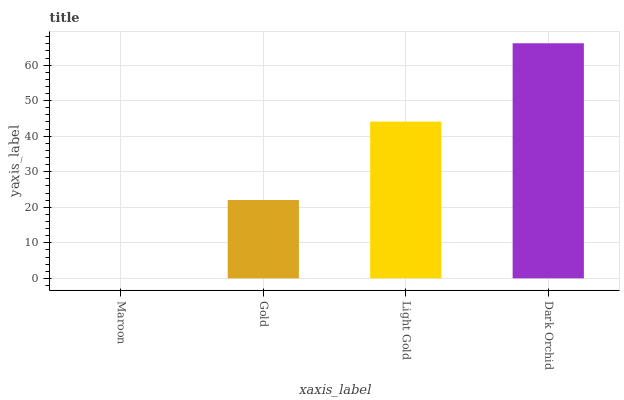Is Maroon the minimum?
Answer yes or no. Yes. Is Dark Orchid the maximum?
Answer yes or no. Yes. Is Gold the minimum?
Answer yes or no. No. Is Gold the maximum?
Answer yes or no. No. Is Gold greater than Maroon?
Answer yes or no. Yes. Is Maroon less than Gold?
Answer yes or no. Yes. Is Maroon greater than Gold?
Answer yes or no. No. Is Gold less than Maroon?
Answer yes or no. No. Is Light Gold the high median?
Answer yes or no. Yes. Is Gold the low median?
Answer yes or no. Yes. Is Dark Orchid the high median?
Answer yes or no. No. Is Maroon the low median?
Answer yes or no. No. 